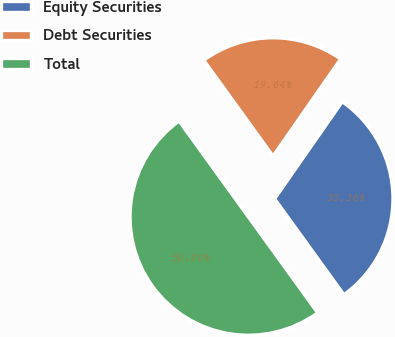Convert chart to OTSL. <chart><loc_0><loc_0><loc_500><loc_500><pie_chart><fcel>Equity Securities<fcel>Debt Securities<fcel>Total<nl><fcel>30.36%<fcel>19.64%<fcel>50.0%<nl></chart> 